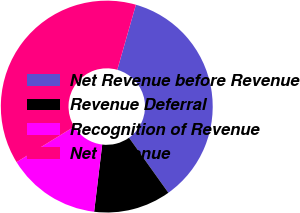Convert chart to OTSL. <chart><loc_0><loc_0><loc_500><loc_500><pie_chart><fcel>Net Revenue before Revenue<fcel>Revenue Deferral<fcel>Recognition of Revenue<fcel>Net Revenue<nl><fcel>35.69%<fcel>11.78%<fcel>14.31%<fcel>38.22%<nl></chart> 